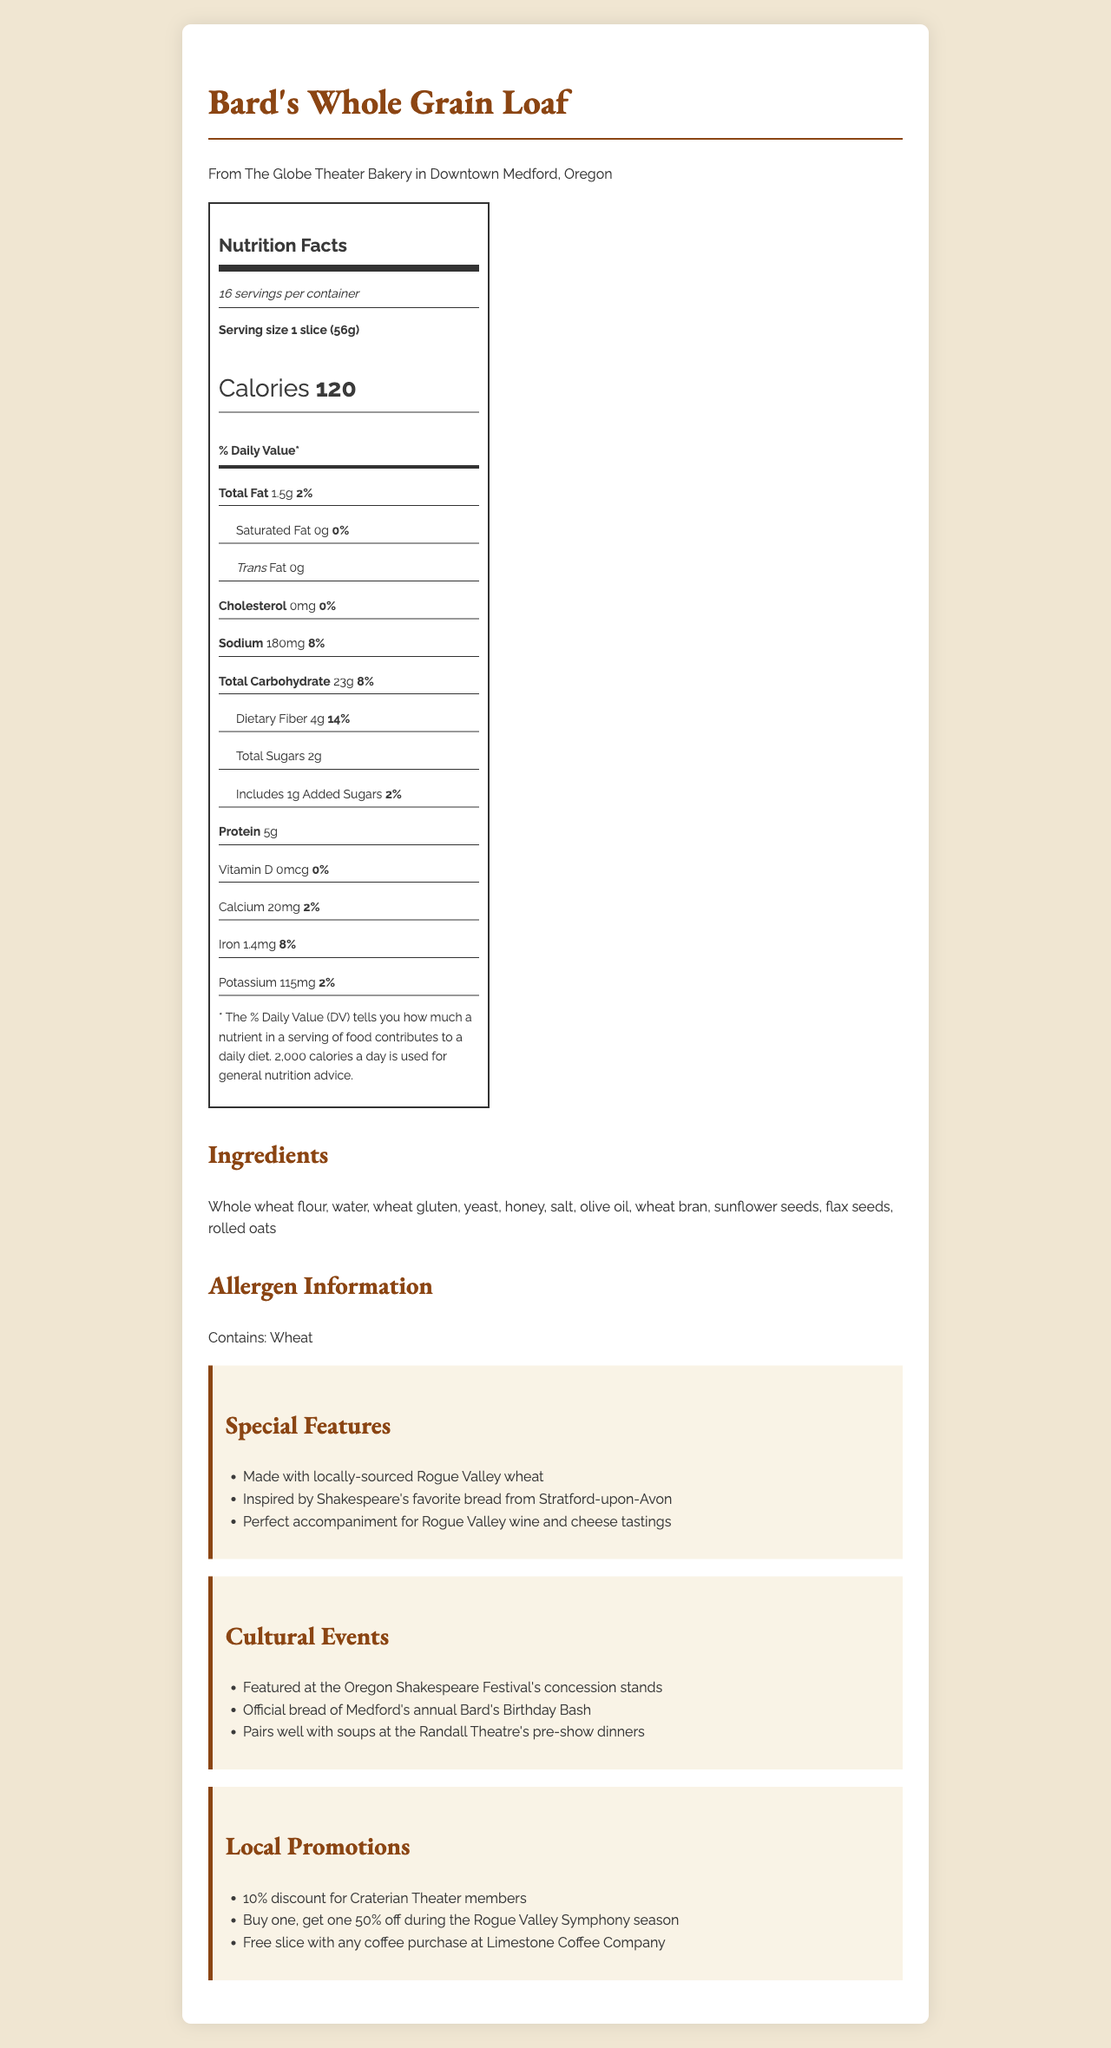what is the serving size of Bard's Whole Grain Loaf? The serving size is clearly mentioned as "1 slice (56g)" in the Nutrition Facts section.
Answer: 1 slice (56g) how many servings are in a container? The document states that there are 16 servings per container.
Answer: 16 how many calories does one serving of Bard's Whole Grain Loaf contain? The Nutrition Facts label lists the calories as 120 per serving.
Answer: 120 what is the total fat content per serving of the bread? The total fat content per serving is indicated as 1.5g.
Answer: 1.5g what percentage of the daily value for dietary fiber does one serving provide? The dietary fiber section lists that one serving provides 14% of the daily value.
Answer: 14% what are the ingredients of Bard's Whole Grain Loaf? The document lists all the ingredients under the Ingredients section.
Answer: Whole wheat flour, water, wheat gluten, yeast, honey, salt, olive oil, wheat bran, sunflower seeds, flax seeds, rolled oats what is the bakery name and location? The bakery details are mentioned at the beginning of the document.
Answer: The Globe Theater Bakery in Downtown Medford, Oregon which Shakespeare-related event features Bard's Whole Grain Loaf? A. Randall Theatre's pre-show dinners B. Oregon Shakespeare Festival's concession stands C. Craterian Theater The document mentions that Bard's Whole Grain Loaf is featured at the Oregon Shakespeare Festival's concession stands.
Answer: B. Oregon Shakespeare Festival's concession stands what allergens are present in the bread? A. Nuts B. Dairy C. Wheat D. Soy The allergen information section states "Contains: Wheat".
Answer: C. Wheat does the bread contain any trans fat? The Nutrition Facts section clearly indicates that the trans fat content is "0g".
Answer: No is the bread made with locally-sourced ingredients? The special features section mentions that the bread is made with locally-sourced Rogue Valley wheat.
Answer: Yes summarize the main idea of the document. The document centers around Bard's Whole Grain Loaf, providing comprehensive nutritional details, ingredient list, and cultural associations to Medford's Shakespeare-themed events, alongside local promotions.
Answer: This document provides detailed nutrition information, ingredients, and allergen details for Bard's Whole Grain Loaf, an artisanal bread from The Globe Theater Bakery in Medford, Oregon. It highlights the product's local sourcing, cultural ties with Shakespeare-themed events, and various local promotions. are there any discounts available for Craterian Theater members? The local promotions section lists a "10% discount for Craterian Theater members".
Answer: Yes how many grams of protein does one serving contain? The Nutrition Facts section lists the protein content as 5g per serving.
Answer: 5g does Bard's Whole Grain Loaf contain added sugars? The Nutrition Facts label states that the bread includes 1g of added sugars.
Answer: Yes is information on the bread's potassium content provided? The Nutrition Facts section lists potassium content as 115mg.
Answer: Yes how much sodium does one serving of this bread contain, and what is the daily value percentage? The Nutrition Facts label provides the sodium content as 180mg and a daily value percentage of 8%.
Answer: 180mg, 8% do we know if the bread is gluten-free? The document does not provide information on whether the bread is gluten-free; it only lists wheat as an allergen.
Answer: Not enough information how much iron is in one serving of Bard's Whole Grain Loaf? The Nutrition Facts label states that the bread contains 1.4mg of iron, which is 8% of the daily value.
Answer: 1.4mg, 8% is there any vitamin D in the bread? The Nutrition Facts label indicates that the amount of vitamin D is 0mcg, with a daily value of 0%.
Answer: No 